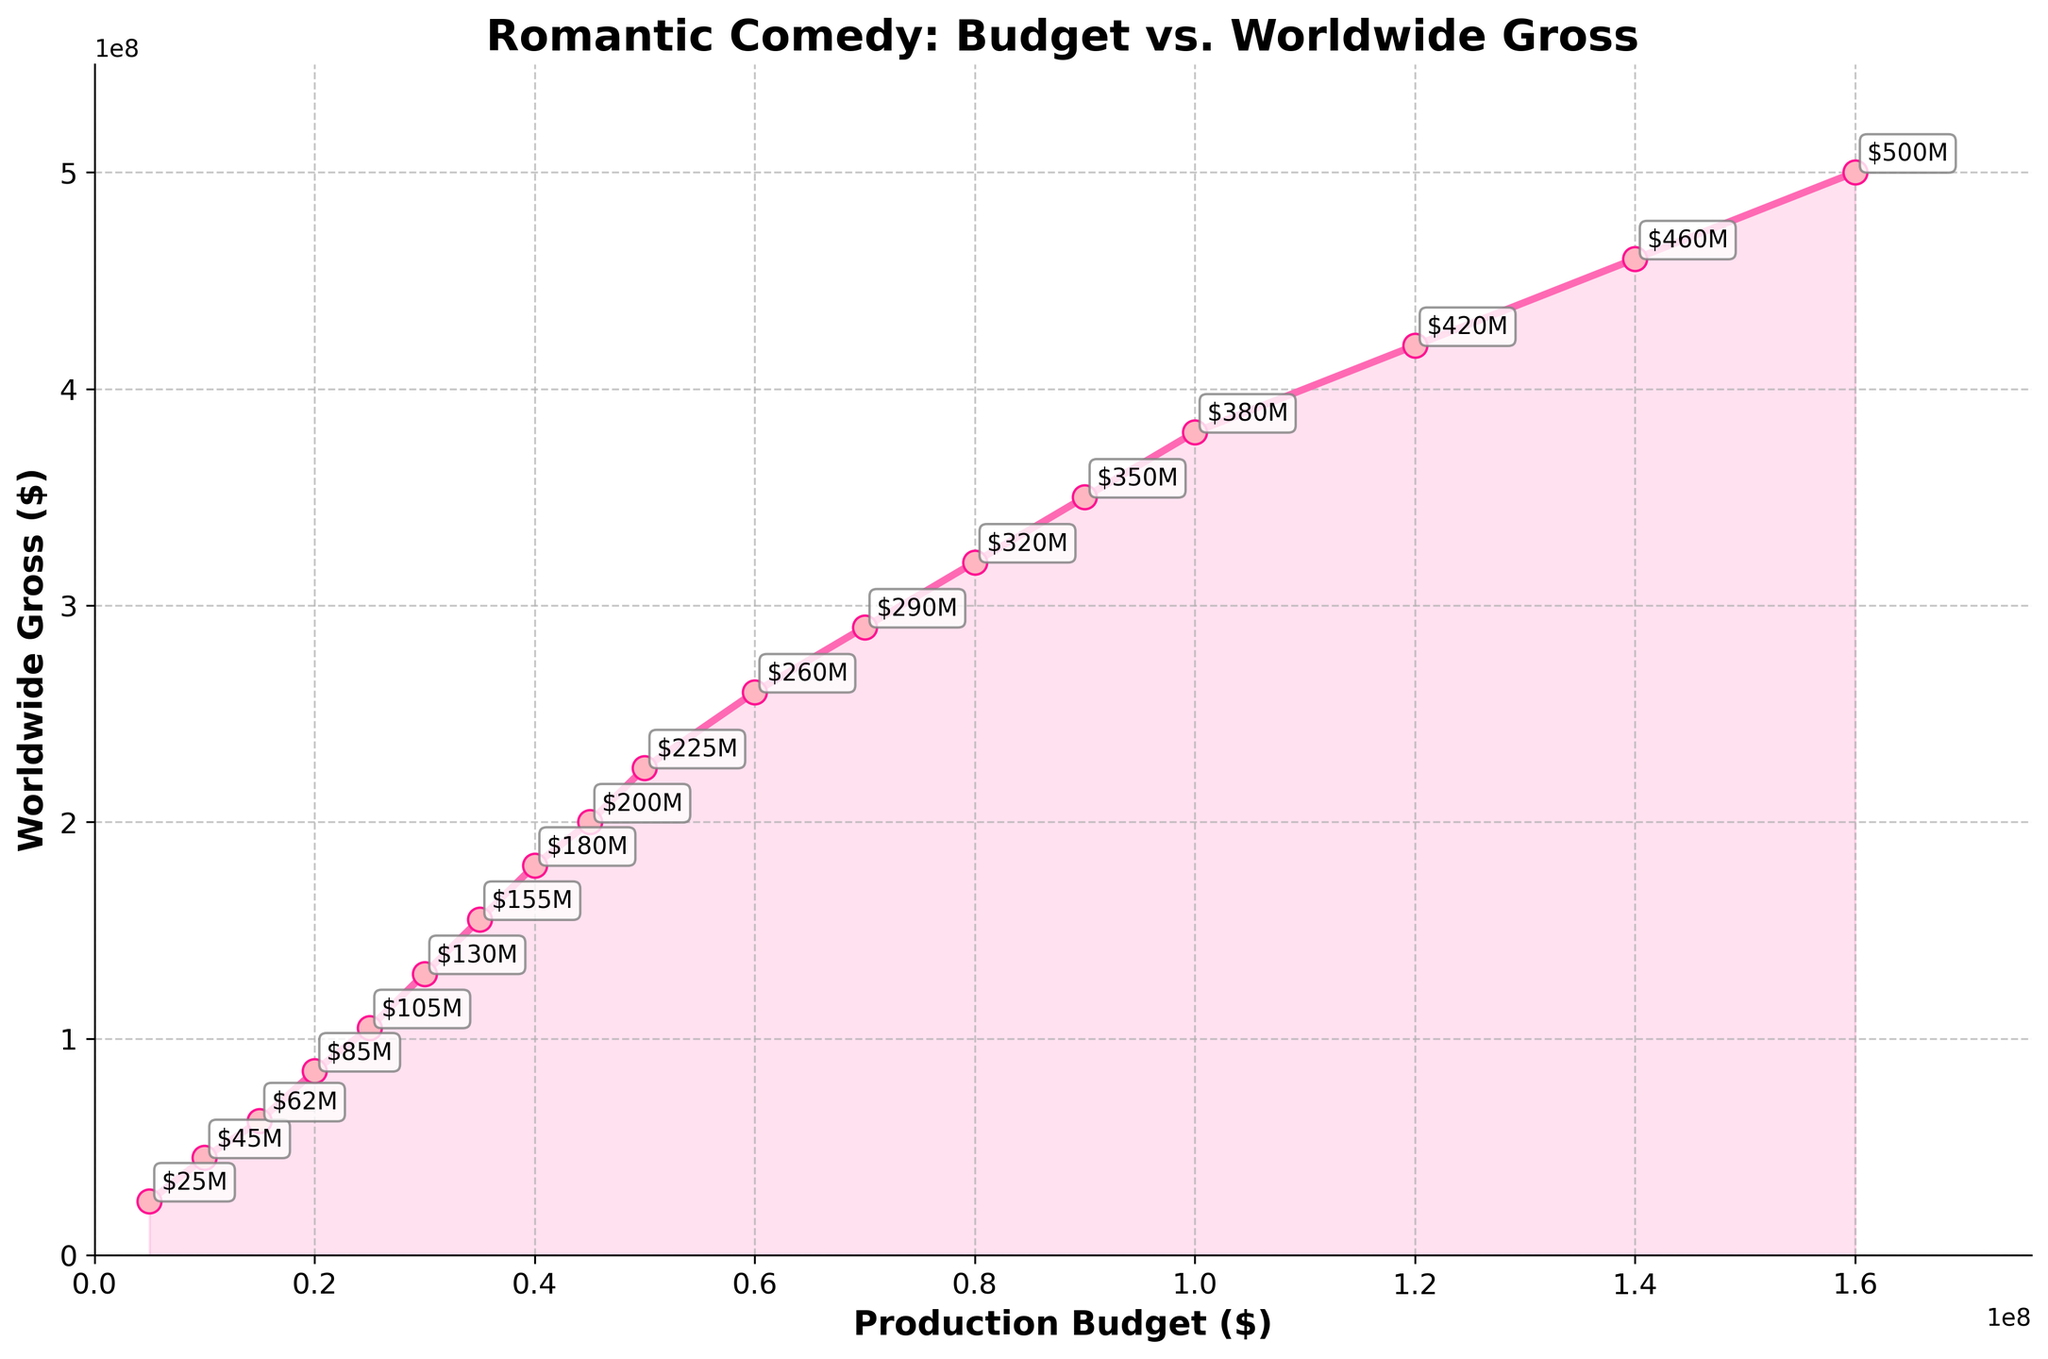What's the worldwide gross for a production budget of $20 million? To determine the worldwide gross for a production budget of $20 million, look at the data point corresponding to $20 million on the x-axis and find its value on the y-axis. The y-axis value shows the worldwide gross.
Answer: $85 million What is the increase in worldwide gross from a production budget of $10 million to $30 million? To find the increase, locate the worldwide gross for both $10 million and $30 million production budgets. Then subtract the gross for $10 million from the gross for $30 million. The worldwide gross for $10 million is $45 million and for $30 million is $130 million. The increase is $130 million - $45 million.
Answer: $85 million Which production budget leads to a worldwide gross of at least $200 million? To find this, scan the y-axis for values equal to or greater than $200 million and trace them back to the corresponding x-axis values (production budgets). For $200 million, the production budget is $45 million, $50 million, or higher.
Answer: $45 million or more How does the slope of the line change as the production budget increases from $5 million to $160 million? Analyze the steepness of the plotted line from the $5 million mark to the $160 million mark. The line continuously rises, showing a consistent positive slope indicating that worldwide gross increases at a steady rate as the production budget increases.
Answer: Consistently positive What is the visual indication used to highlight the area under the relationship curve? Look at the area below the line that plots the relationship between production budget and worldwide gross. This area is visually highlighted by a shade.
Answer: Shaded/fill between By how much does the worldwide gross change on average with each $10 million increase in production budget between $50 million and $150 million? Identify worldwide gross points at $50 million, $60 million, $70 million, $80 million, $90 million, $100 million, $120 million, $140 million. Calculate the differences between each consecutive $10 million and find the average. Grosses are $225M, $260M, $290M, $320M, $350M, $380M, $420M, $460M. Changes are $35M, $30M, $30M, $30M, $30M, $30M, $40M. Average change = ($35 + $30 + $30 + $30 + $30 + $30 + $40) / 7.
Answer: $32.14 million Which data point has the steepest annotation? Identify the data point where the annotation text appears most vertically steep in orientation. This is often where there's a sharp increase in worldwide gross. The steepest annotation appears around the point with a $500 million worldwide gross.
Answer: $160 million Is the relationship between production budget and worldwide gross linear or non-linear? Examine the overall shape of the plot line. The relationship, given the gradual and steady upward slope without any significant flattening or steep drops, suggests a linear pattern.
Answer: Linear 